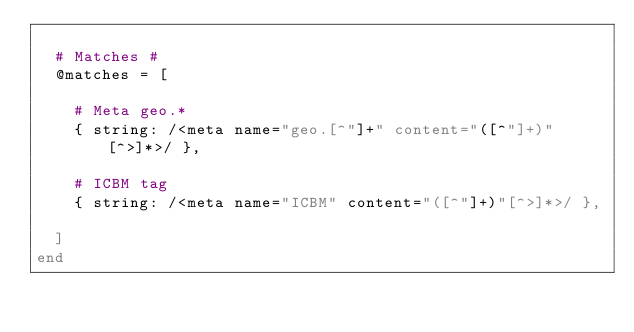Convert code to text. <code><loc_0><loc_0><loc_500><loc_500><_Ruby_>
  # Matches #
  @matches = [

    # Meta geo.*
    { string: /<meta name="geo.[^"]+" content="([^"]+)"[^>]*>/ },

    # ICBM tag
    { string: /<meta name="ICBM" content="([^"]+)"[^>]*>/ },

  ]
end
</code> 